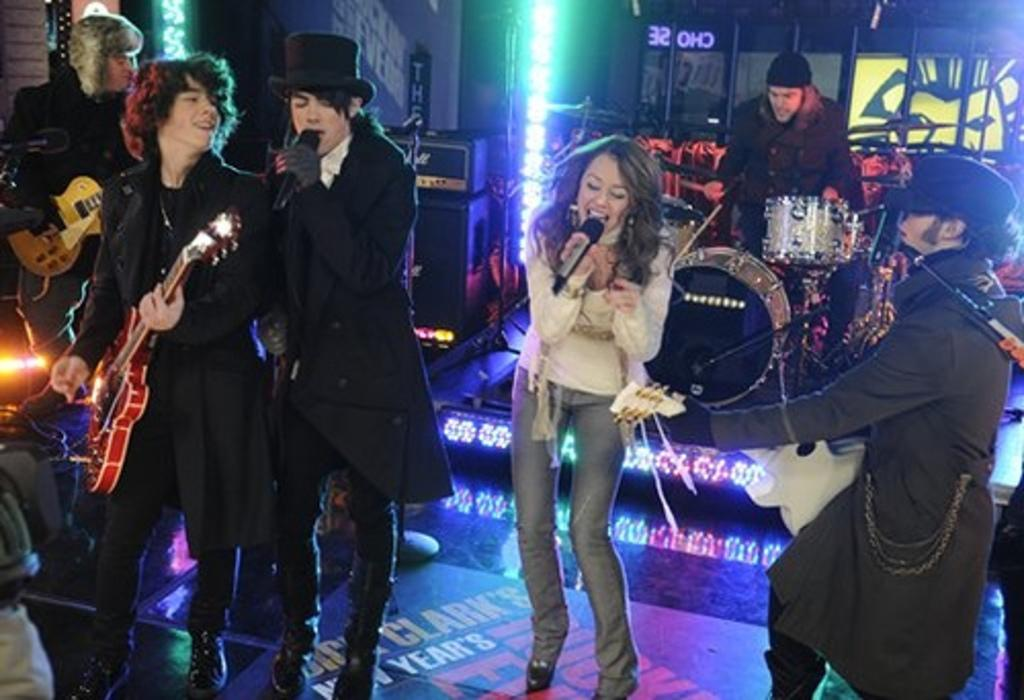What are the people in the image doing? There are persons standing on the floor, one person is playing drums, two persons are playing guitar, and one person is singing on a microphone. What instruments are being played in the image? Drums and guitars are being played in the image. What is the person with the microphone doing? The person with the microphone is singing. What type of gold drink is being served to the musicians in the image? There is no drink, gold or otherwise, present in the image. 